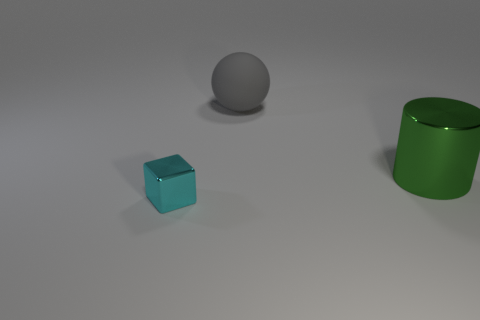Does the object in front of the large shiny cylinder have the same material as the big thing in front of the matte sphere?
Your answer should be compact. Yes. Does the thing in front of the large green cylinder have the same color as the sphere?
Offer a very short reply. No. How many big gray rubber objects are in front of the gray matte thing?
Your answer should be compact. 0. Are the tiny block and the thing right of the large gray matte sphere made of the same material?
Provide a succinct answer. Yes. There is a thing that is made of the same material as the small block; what is its size?
Make the answer very short. Large. Are there more large green cylinders that are to the left of the green metal thing than large metal things that are right of the gray thing?
Your answer should be compact. No. Is there another tiny purple rubber object of the same shape as the tiny object?
Offer a very short reply. No. Is the size of the metal thing that is left of the green thing the same as the gray matte sphere?
Give a very brief answer. No. Are any big brown blocks visible?
Your answer should be very brief. No. How many objects are either large objects that are in front of the ball or small brown balls?
Provide a succinct answer. 1. 